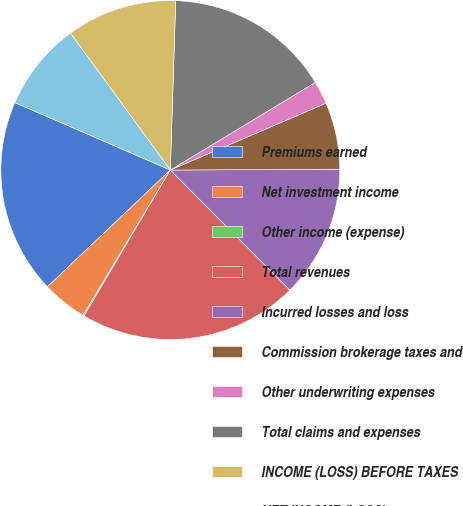<chart> <loc_0><loc_0><loc_500><loc_500><pie_chart><fcel>Premiums earned<fcel>Net investment income<fcel>Other income (expense)<fcel>Total revenues<fcel>Incurred losses and loss<fcel>Commission brokerage taxes and<fcel>Other underwriting expenses<fcel>Total claims and expenses<fcel>INCOME (LOSS) BEFORE TAXES<fcel>NET INCOME (LOSS)<nl><fcel>18.61%<fcel>4.29%<fcel>0.12%<fcel>20.96%<fcel>12.62%<fcel>6.37%<fcel>2.2%<fcel>15.84%<fcel>10.54%<fcel>8.45%<nl></chart> 